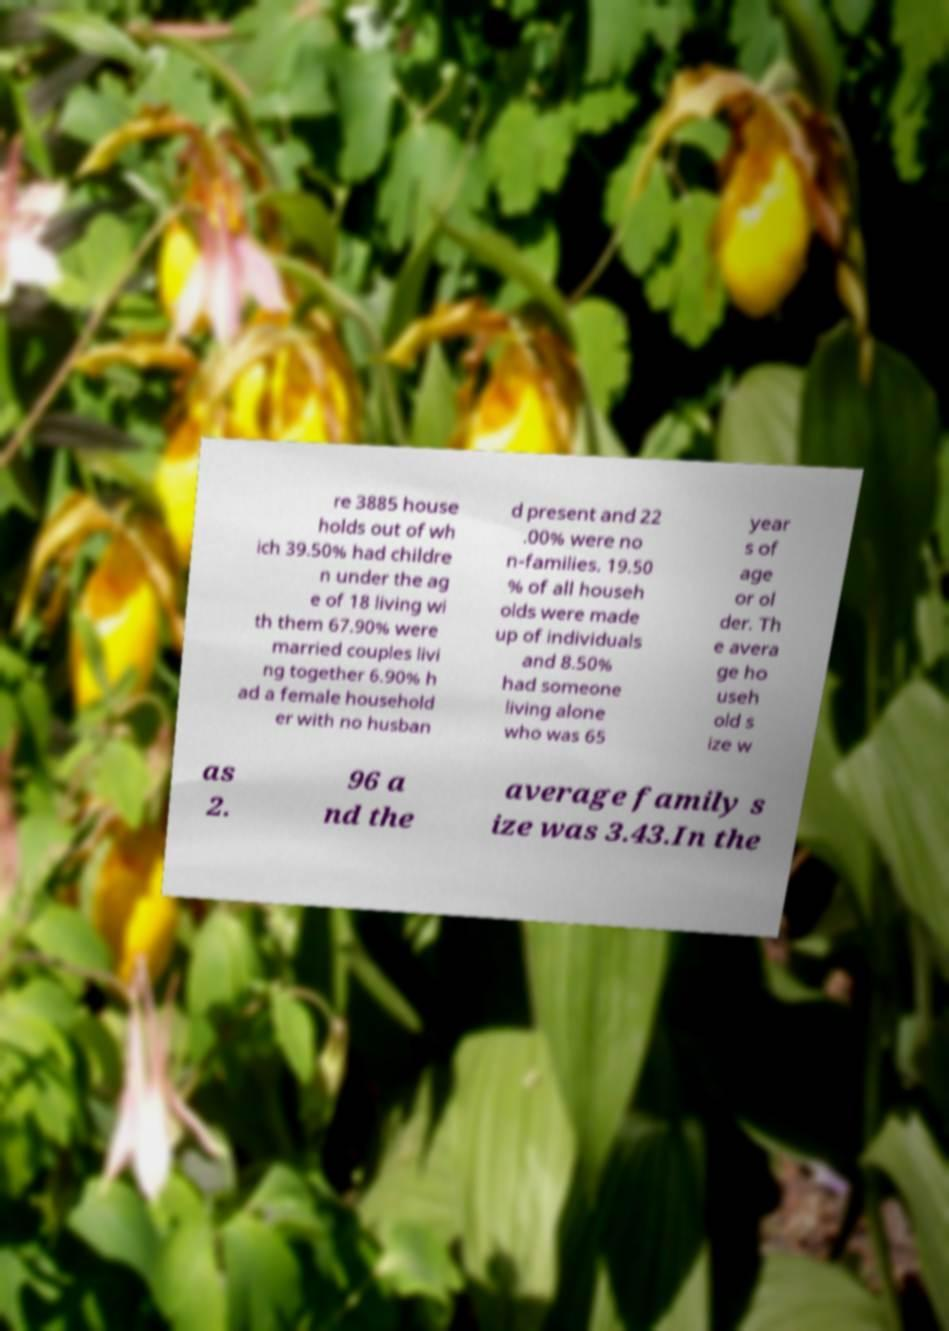Please identify and transcribe the text found in this image. re 3885 house holds out of wh ich 39.50% had childre n under the ag e of 18 living wi th them 67.90% were married couples livi ng together 6.90% h ad a female household er with no husban d present and 22 .00% were no n-families. 19.50 % of all househ olds were made up of individuals and 8.50% had someone living alone who was 65 year s of age or ol der. Th e avera ge ho useh old s ize w as 2. 96 a nd the average family s ize was 3.43.In the 